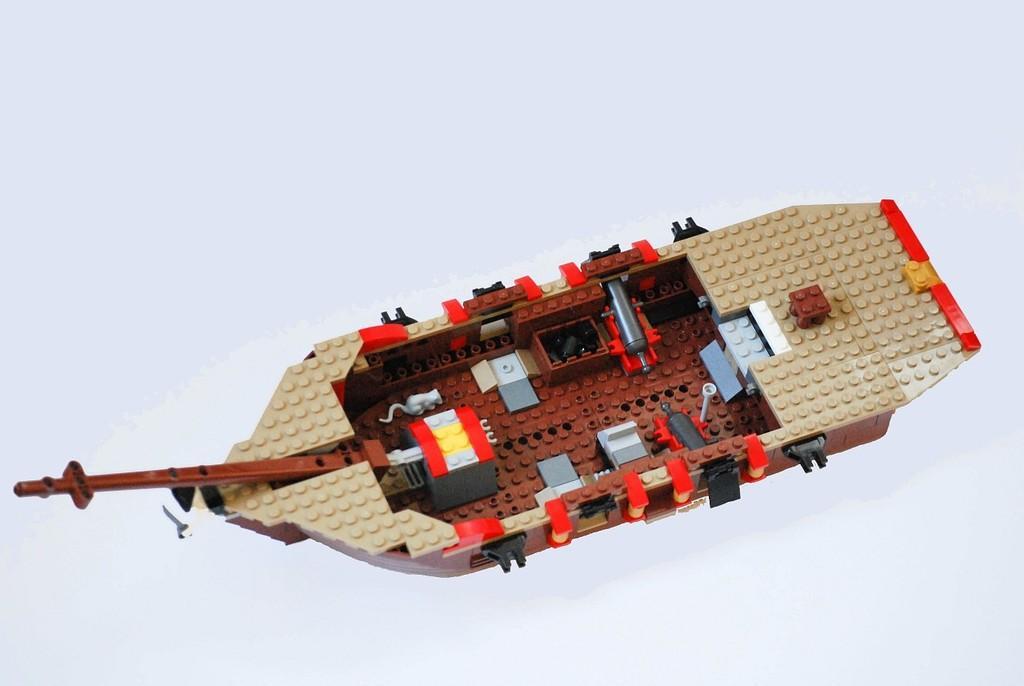In one or two sentences, can you explain what this image depicts? This image consists of a boat made up of miniature. The background is white in color. 